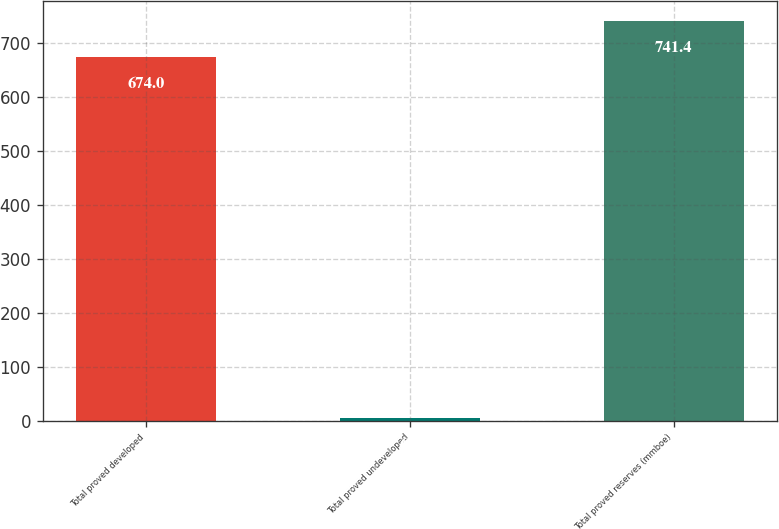<chart> <loc_0><loc_0><loc_500><loc_500><bar_chart><fcel>Total proved developed<fcel>Total proved undeveloped<fcel>Total proved reserves (mmboe)<nl><fcel>674<fcel>6<fcel>741.4<nl></chart> 